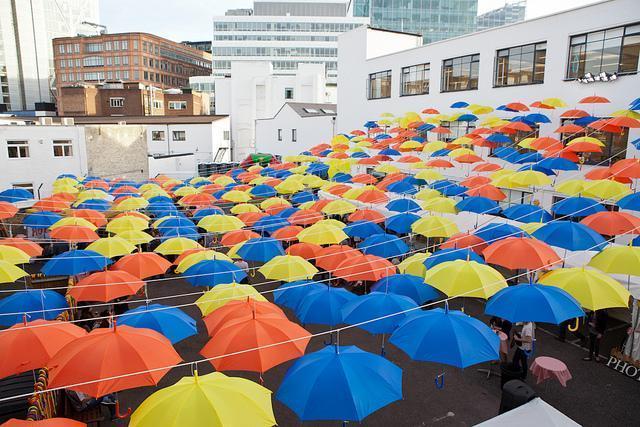How many umbrellas are there?
Give a very brief answer. 3. How many bears are there?
Give a very brief answer. 0. 